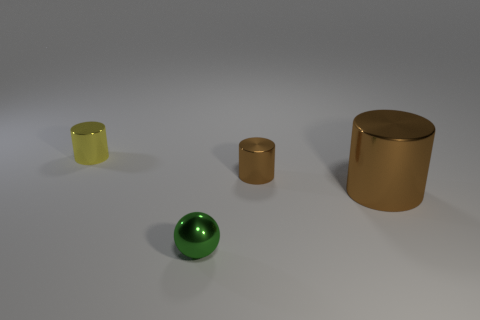Are there any other yellow objects made of the same material as the large thing?
Keep it short and to the point. Yes. There is a brown object that is the same size as the yellow shiny thing; what material is it?
Give a very brief answer. Metal. There is a tiny thing right of the tiny green metal ball; is its color the same as the small object on the left side of the small green thing?
Provide a succinct answer. No. Is there a metal object that is in front of the tiny cylinder that is on the right side of the yellow cylinder?
Provide a succinct answer. Yes. There is a tiny metallic thing that is on the left side of the tiny green metal sphere; is it the same shape as the tiny thing on the right side of the metal sphere?
Provide a succinct answer. Yes. Is the material of the yellow cylinder that is left of the metal sphere the same as the small thing to the right of the shiny sphere?
Your response must be concise. Yes. What material is the tiny cylinder behind the tiny brown shiny thing that is on the right side of the shiny ball?
Your response must be concise. Metal. There is a brown metal object to the left of the metal cylinder in front of the brown metal object left of the big brown cylinder; what shape is it?
Keep it short and to the point. Cylinder. What material is the other yellow object that is the same shape as the big metal object?
Offer a very short reply. Metal. How many big brown metallic cylinders are there?
Ensure brevity in your answer.  1. 